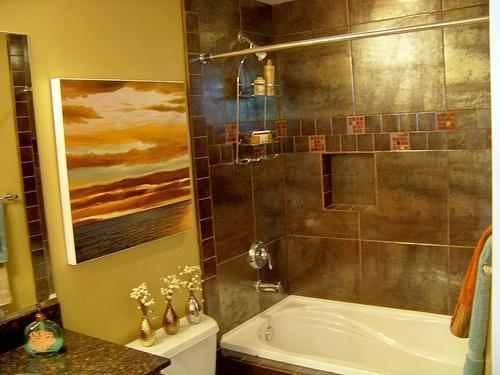How many paintings?
Give a very brief answer. 1. 